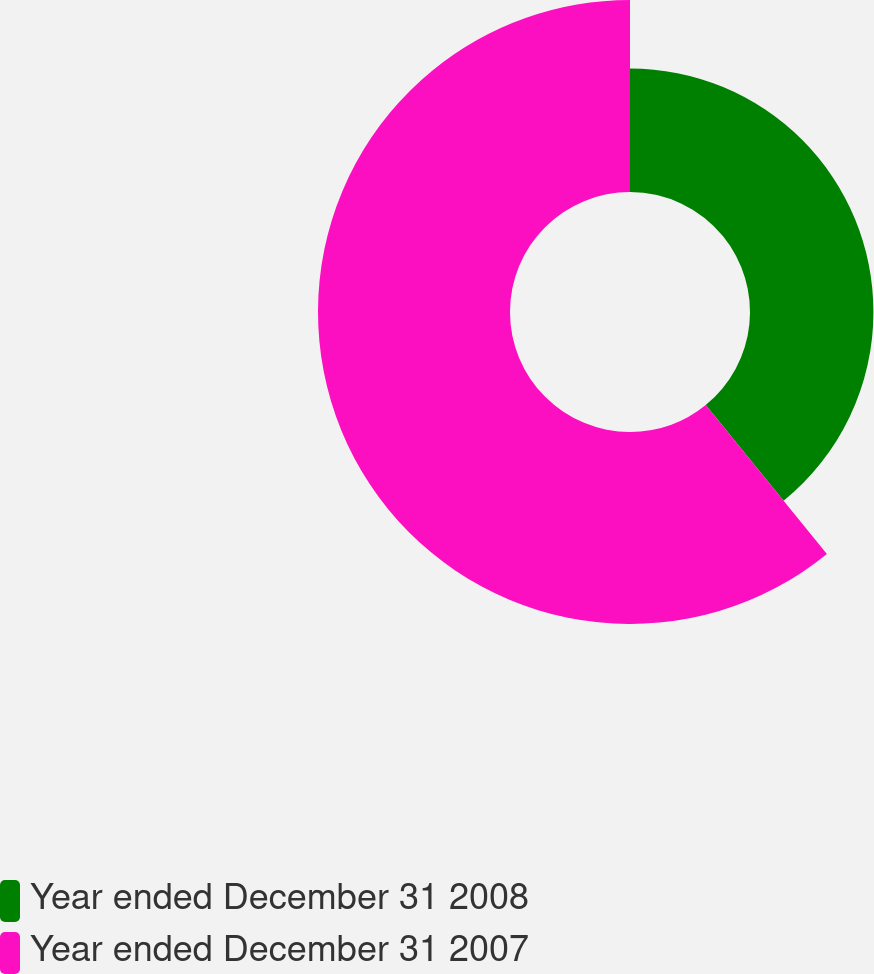<chart> <loc_0><loc_0><loc_500><loc_500><pie_chart><fcel>Year ended December 31 2008<fcel>Year ended December 31 2007<nl><fcel>39.13%<fcel>60.87%<nl></chart> 